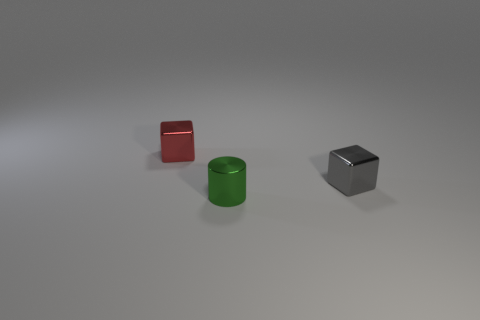Add 3 big purple rubber things. How many objects exist? 6 Subtract all cylinders. How many objects are left? 2 Add 2 tiny objects. How many tiny objects are left? 5 Add 2 tiny gray shiny objects. How many tiny gray shiny objects exist? 3 Subtract 0 purple cylinders. How many objects are left? 3 Subtract all tiny green cylinders. Subtract all shiny blocks. How many objects are left? 0 